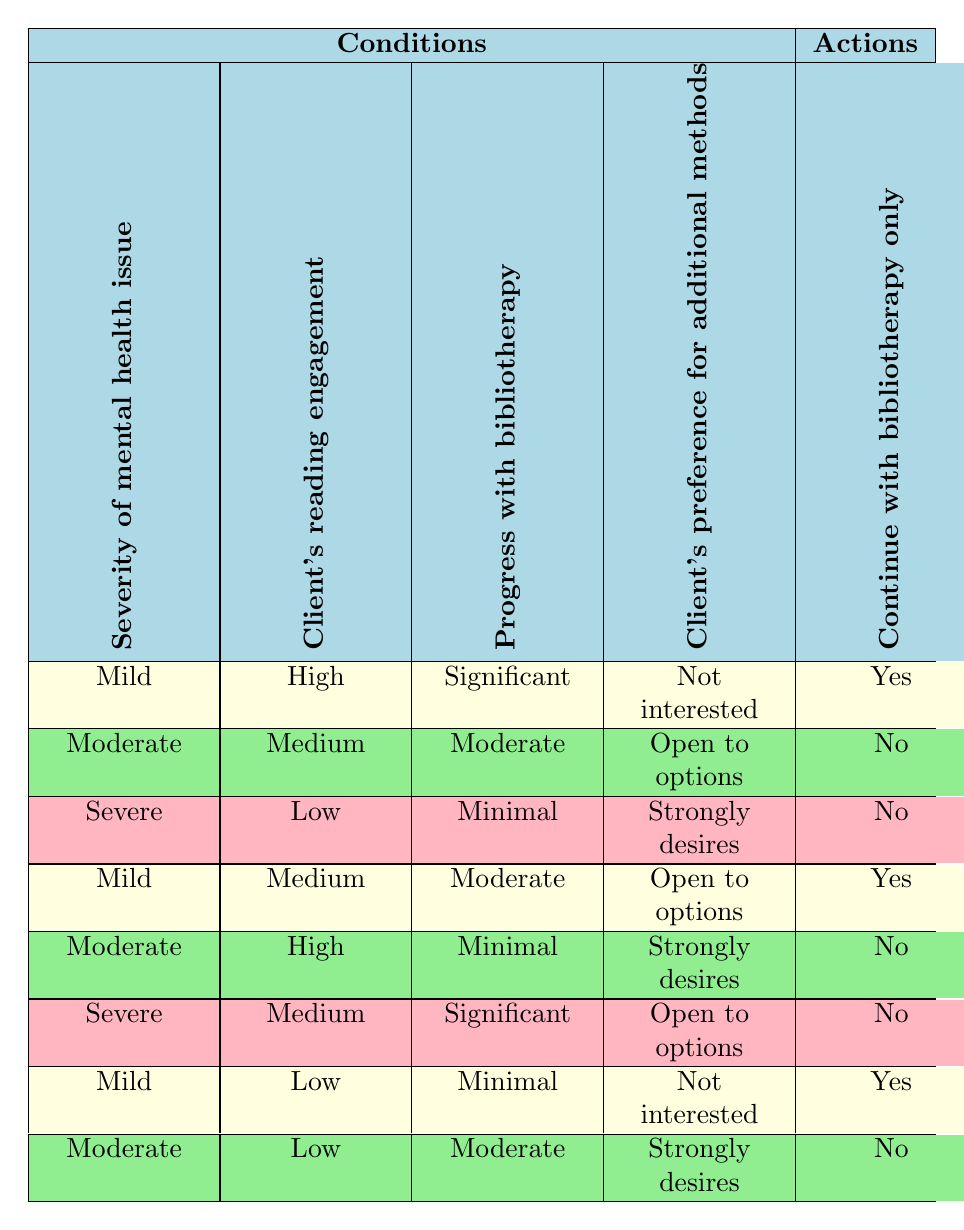What actions are suggested when the severity of the mental health issue is moderate, reading engagement is medium, progress with bibliotherapy is moderate, and the client is open to options? By examining the corresponding row in the table, we find that the actions taken are to not continue with bibliotherapy only, introduce Cognitive Behavioral Therapy, incorporate mindfulness techniques, suggest group therapy sessions, and recommend art therapy. Therefore, the suggested actions are "No, Yes, Yes, No, No."
Answer: No, Yes, Yes, No, No How many actions recommend introducing Cognitive Behavioral Therapy across all conditions? To find this, we look for all rows where the action for introducing Cognitive Behavioral Therapy is "Yes." There are four rows that meet this condition: 2, 3, 5, and 6. Thus, the total number of recommendations for introducing CBT is 4.
Answer: 4 Is there a scenario when a client with a severe mental health issue and low reading engagement would not be encouraged to incorporate mindfulness techniques? Reviewing the rows for severe mental health issues with low reading engagement shows that in the only relevant row, when the client's progress with bibliotherapy is minimal and there is a strong desire for additional methods, it recommends incorporating mindfulness techniques. Thus, there is no scenario that fits the criteria where mindfulness techniques are not encouraged.
Answer: No What is the action recommended when the client's reading engagement is high, but they show minimal progress with bibliotherapy, and have a strong desire for additional therapies? Looking at the row where the reading engagement is high, progress is minimal, and the client strongly desires additional methods, the actions taken are not to continue with bibliotherapy only, to introduce Cognitive Behavioral Therapy, but no details for mindfulness techniques, group therapy, or art therapy. Therefore, the recommended actions would be "No, Yes, No, Yes, No."
Answer: No, Yes, No, Yes, No In how many scenarios would a client with mild severity, low engagement, and minimal progress not have any additional therapies recommended? For this, we check each row for conditions that match mild severity, low engagement, and minimal progress. There is one relevant row in the table that meets these criteria, and it recommends continuing with bibliotherapy only. So there is one scenario where no additional therapies are recommended.
Answer: 1 